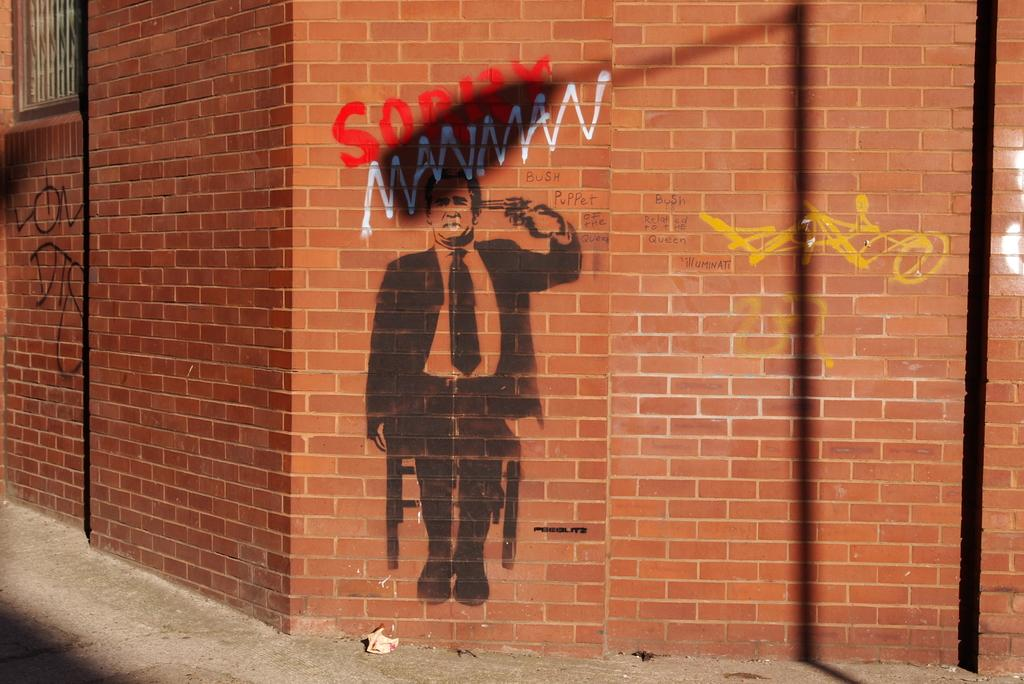What can be seen on the wall in the image? There are paintings on the wall in the image. What type of hammer is hanging on the wall next to the paintings? There is no hammer present in the image; only paintings are visible on the wall. 